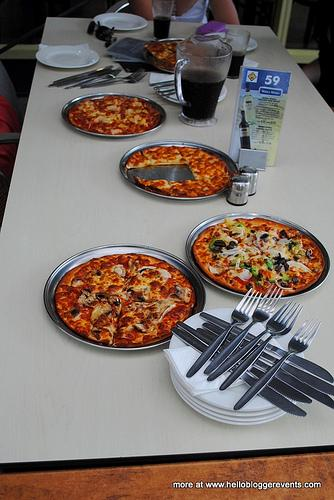What can you surmise about the table setting in the image? The table is set with various utensils, plates, and pizzas, indicating a meal or party. Explain the different aspects of the pitchers in the image. There are no pitchers visible in the image. Mention the types of utensils present in the image. There are forks and knives featured in the image. Explain the different types of food and drink items in the image. The image consists of four pizzas on pans. Identify the primary objects in the image and their locations. Four pizzas on pans, a stack of white plates, several forks and knives. Provide a brief overview of the items and actions depicted in the image. The image shows various tableware items such as forks, knives, and plates, along with pizzas on pans. Describe the image's primary contents in a single sentence. The image mainly contains tableware items such as forks and knives, along with four pizzas. State the distinguishing characteristics of the plates in the image. The plates are white and piled up on the table. Provide a summary of the captions related to the pizza. The pizzas are on pans, each with different toppings, and one of the pizzas has some missing pieces. Describe the appearance and attributes of the forks in the image. The forks are silver, made of metal, shiny, and are possibly made of steel. 